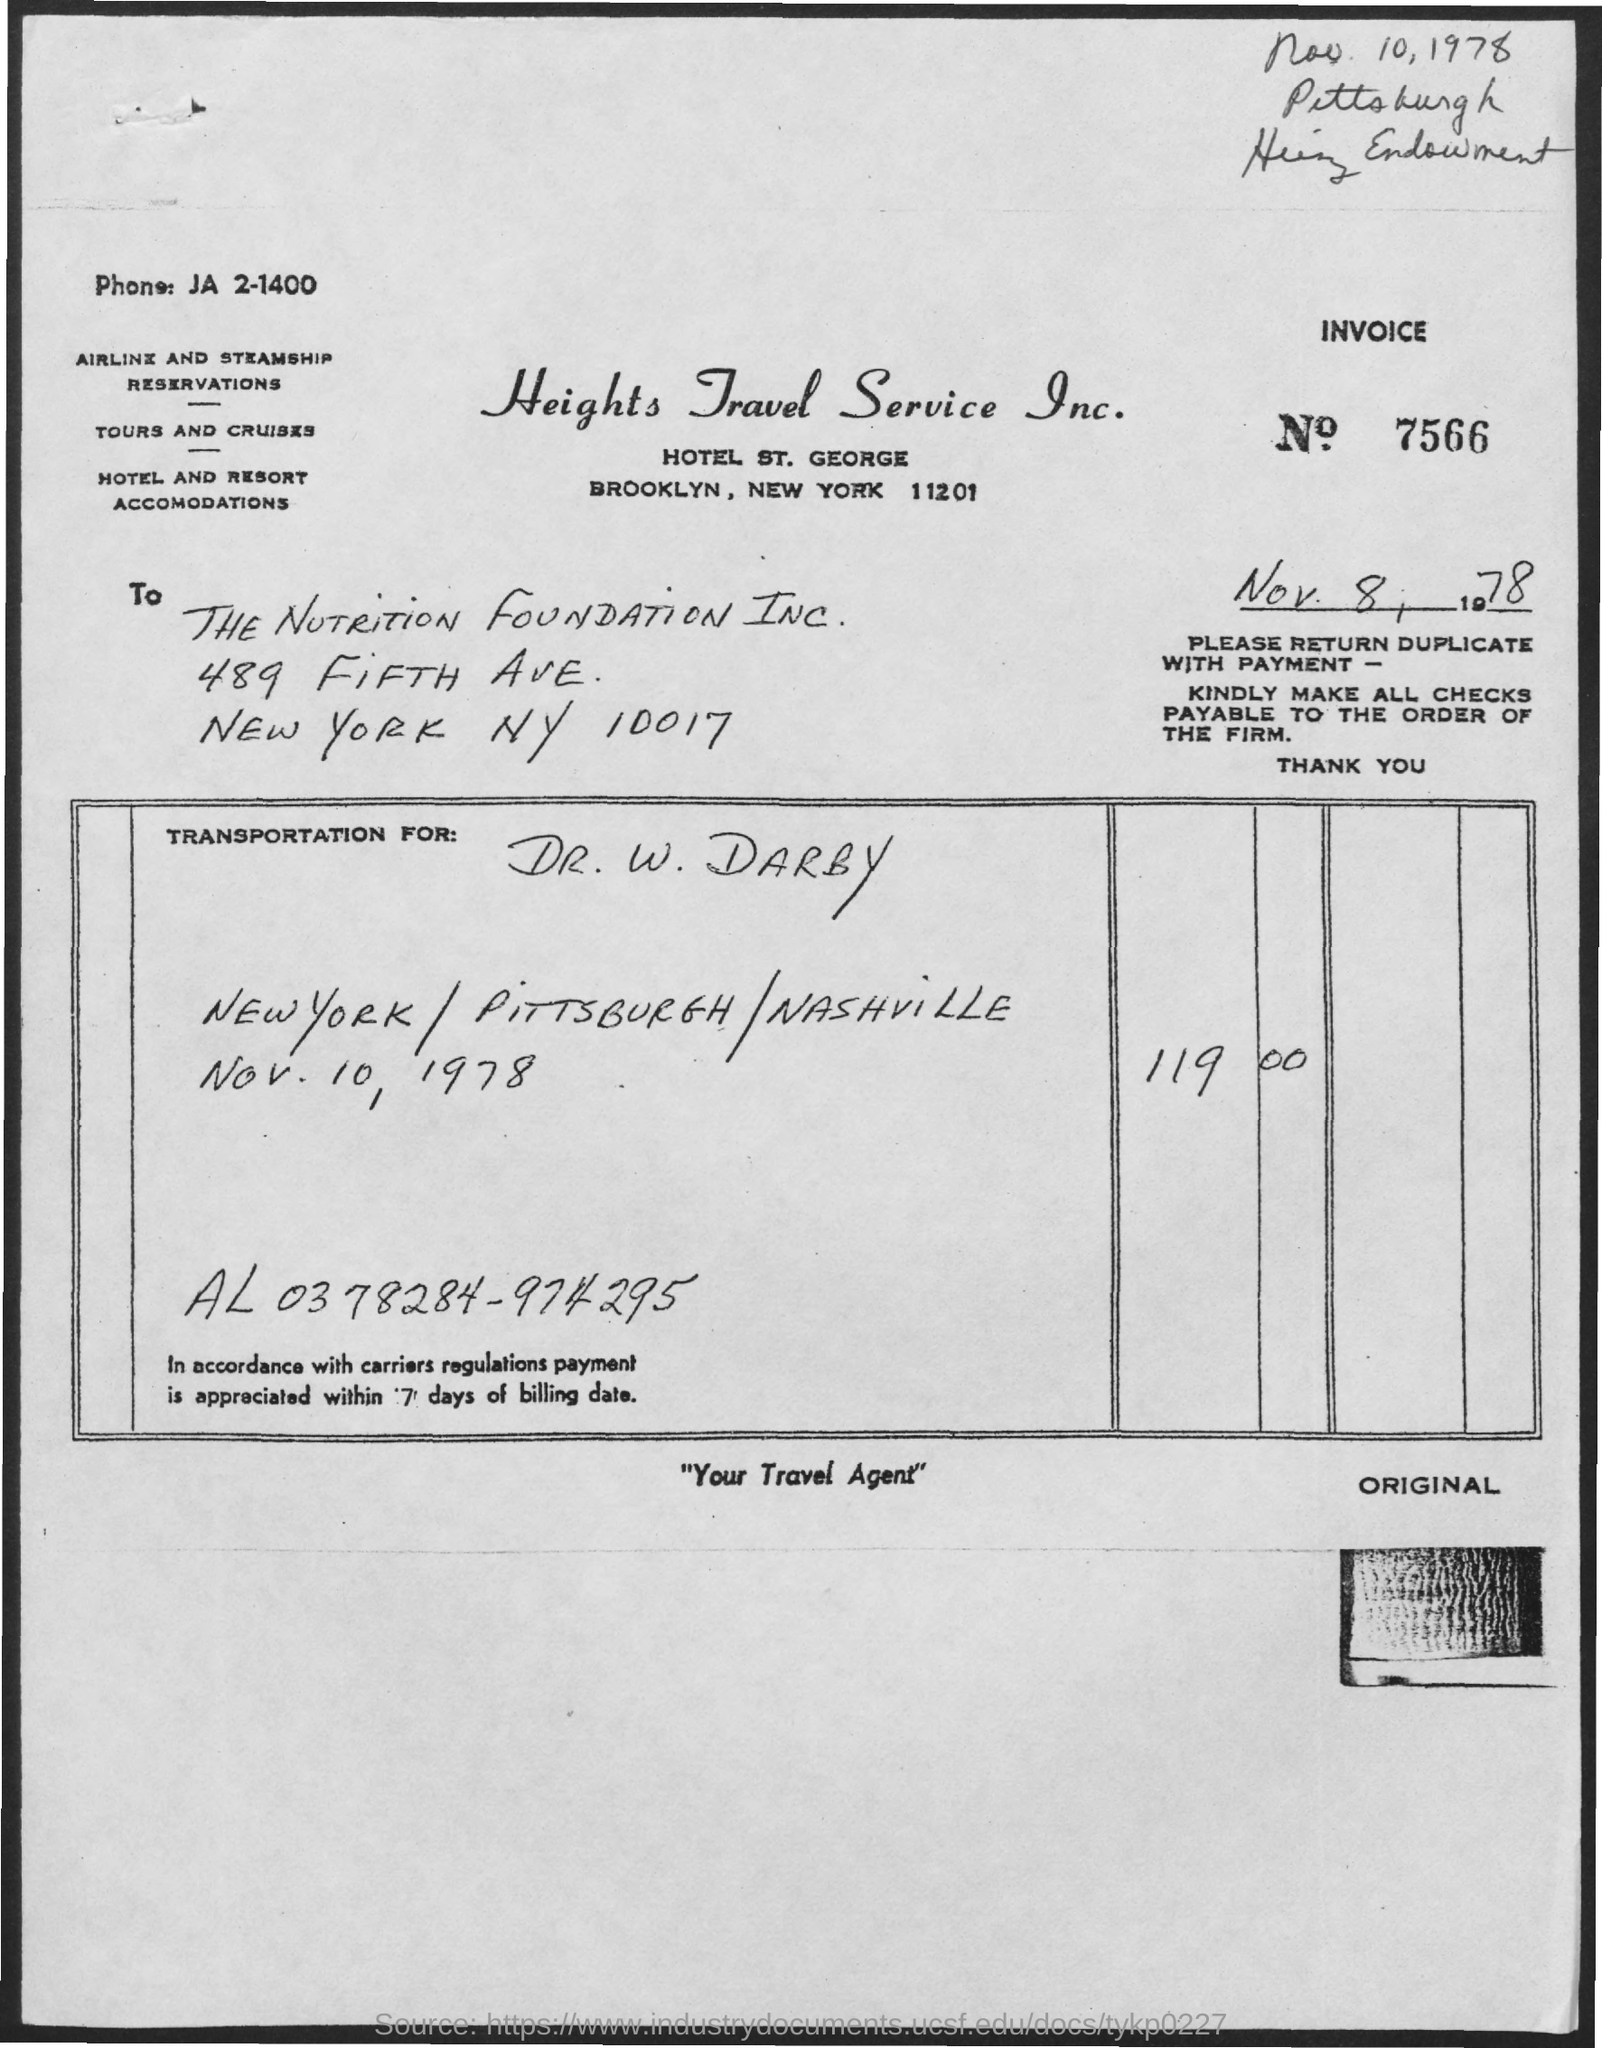What is the issued date of the invoice?
Your response must be concise. Nov. 8, 1978. What is the Invoice No mentioned in this document?
Provide a succinct answer. 7566. Which company is raising the invoice?
Give a very brief answer. Heights Travel Service Inc. What is the phone no of Heights Travel Service Inc. given?
Make the answer very short. JA 2-1400. To whom, the invoice is addressed?
Provide a short and direct response. THE NUTRITION FOUNDATION INC. What is the invoice amount on transportation for Dr. W. DARBY dated Nov. 10, 1978?
Your answer should be very brief. 119.00. 